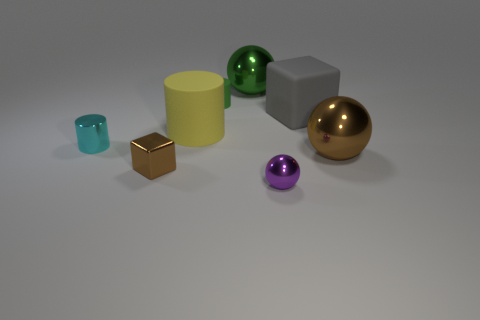There is a brown shiny object that is to the left of the large ball in front of the big green ball; what number of purple shiny spheres are to the left of it?
Offer a very short reply. 0. There is a brown thing that is to the left of the tiny purple metallic thing; is it the same size as the rubber cylinder behind the large yellow object?
Your answer should be compact. Yes. There is another big object that is the same shape as the large brown thing; what is its material?
Ensure brevity in your answer.  Metal. How many small objects are purple balls or gray cubes?
Give a very brief answer. 1. What is the material of the small brown thing?
Ensure brevity in your answer.  Metal. There is a small object that is both in front of the small rubber cylinder and on the right side of the big yellow thing; what is its material?
Give a very brief answer. Metal. There is a metal cylinder; does it have the same color as the big ball that is behind the yellow matte thing?
Keep it short and to the point. No. What is the material of the green object that is the same size as the yellow cylinder?
Offer a terse response. Metal. Are there any other cylinders that have the same material as the big yellow cylinder?
Your answer should be very brief. Yes. How many yellow things are there?
Make the answer very short. 1. 